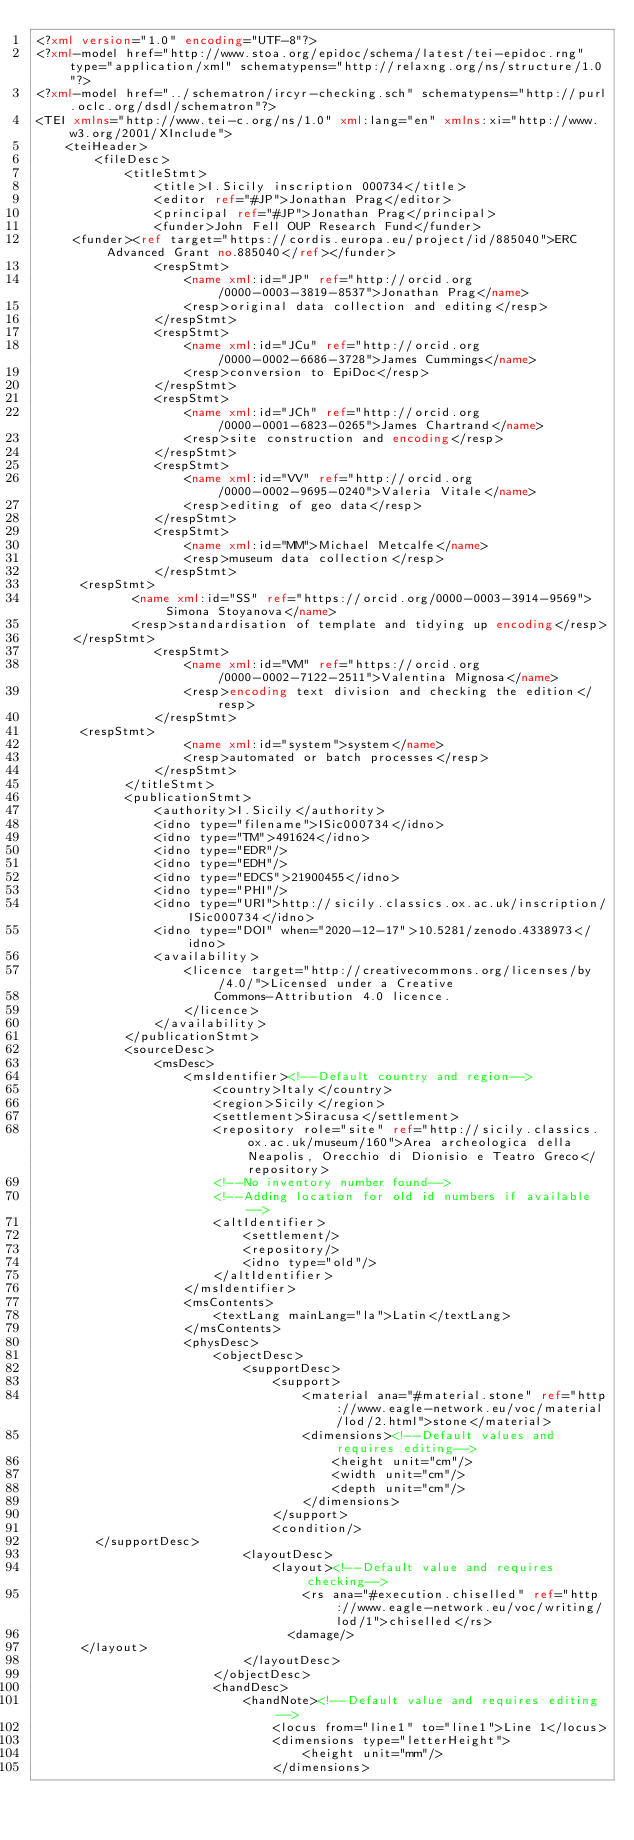<code> <loc_0><loc_0><loc_500><loc_500><_XML_><?xml version="1.0" encoding="UTF-8"?>
<?xml-model href="http://www.stoa.org/epidoc/schema/latest/tei-epidoc.rng" type="application/xml" schematypens="http://relaxng.org/ns/structure/1.0"?>
<?xml-model href="../schematron/ircyr-checking.sch" schematypens="http://purl.oclc.org/dsdl/schematron"?>                                                
<TEI xmlns="http://www.tei-c.org/ns/1.0" xml:lang="en" xmlns:xi="http://www.w3.org/2001/XInclude">
    <teiHeader>
        <fileDesc>
            <titleStmt>
                <title>I.Sicily inscription 000734</title>
                <editor ref="#JP">Jonathan Prag</editor>
                <principal ref="#JP">Jonathan Prag</principal>
                <funder>John Fell OUP Research Fund</funder>
	   <funder><ref target="https://cordis.europa.eu/project/id/885040">ERC Advanced Grant no.885040</ref></funder>
                <respStmt>
                    <name xml:id="JP" ref="http://orcid.org/0000-0003-3819-8537">Jonathan Prag</name>
                    <resp>original data collection and editing</resp>
                </respStmt>
                <respStmt>
                    <name xml:id="JCu" ref="http://orcid.org/0000-0002-6686-3728">James Cummings</name>
                    <resp>conversion to EpiDoc</resp>
                </respStmt>
                <respStmt>
                    <name xml:id="JCh" ref="http://orcid.org/0000-0001-6823-0265">James Chartrand</name>
                    <resp>site construction and encoding</resp>
                </respStmt>
                <respStmt>
                    <name xml:id="VV" ref="http://orcid.org/0000-0002-9695-0240">Valeria Vitale</name>
                    <resp>editing of geo data</resp>
                </respStmt>
                <respStmt>
                    <name xml:id="MM">Michael Metcalfe</name>
                    <resp>museum data collection</resp>
                </respStmt>
	    <respStmt>
     	       <name xml:id="SS" ref="https://orcid.org/0000-0003-3914-9569">Simona Stoyanova</name>
     	       <resp>standardisation of template and tidying up encoding</resp>
 	   </respStmt>
                <respStmt>
                    <name xml:id="VM" ref="https://orcid.org/0000-0002-7122-2511">Valentina Mignosa</name>
                    <resp>encoding text division and checking the edition</resp>
                </respStmt>
	    <respStmt>
                    <name xml:id="system">system</name>
                    <resp>automated or batch processes</resp>
                </respStmt>
            </titleStmt>
            <publicationStmt>
                <authority>I.Sicily</authority>
                <idno type="filename">ISic000734</idno>
                <idno type="TM">491624</idno>
                <idno type="EDR"/>
                <idno type="EDH"/>
                <idno type="EDCS">21900455</idno>
                <idno type="PHI"/>
                <idno type="URI">http://sicily.classics.ox.ac.uk/inscription/ISic000734</idno>
                <idno type="DOI" when="2020-12-17">10.5281/zenodo.4338973</idno>
                <availability>
                    <licence target="http://creativecommons.org/licenses/by/4.0/">Licensed under a Creative
                        Commons-Attribution 4.0 licence.
                    </licence>
                </availability>
            </publicationStmt>
            <sourceDesc>
                <msDesc>
                    <msIdentifier><!--Default country and region-->
                        <country>Italy</country>
                        <region>Sicily</region>
                        <settlement>Siracusa</settlement>
                        <repository role="site" ref="http://sicily.classics.ox.ac.uk/museum/160">Area archeologica della Neapolis, Orecchio di Dionisio e Teatro Greco</repository>
                        <!--No inventory number found-->
                        <!--Adding location for old id numbers if available-->
                        <altIdentifier>
                            <settlement/>
                            <repository/>
                            <idno type="old"/>
                        </altIdentifier>
                    </msIdentifier>
                    <msContents>
                        <textLang mainLang="la">Latin</textLang>
                    </msContents>
                    <physDesc>
                        <objectDesc>
                            <supportDesc>
                                <support>
                                    <material ana="#material.stone" ref="http://www.eagle-network.eu/voc/material/lod/2.html">stone</material>
                                    <dimensions><!--Default values and requires editing-->
                                        <height unit="cm"/>
                                        <width unit="cm"/>
                                        <depth unit="cm"/>
                                    </dimensions>
                                </support>
                                <condition/>
		    </supportDesc>
                            <layoutDesc>
                                <layout><!--Default value and requires checking-->
                                    <rs ana="#execution.chiselled" ref="http://www.eagle-network.eu/voc/writing/lod/1">chiselled</rs>
                                	<damage/>
			</layout>
                            </layoutDesc>
                        </objectDesc>
                        <handDesc>
                            <handNote><!--Default value and requires editing-->
                                <locus from="line1" to="line1">Line 1</locus>
                                <dimensions type="letterHeight">
                                    <height unit="mm"/>
                                </dimensions></code> 